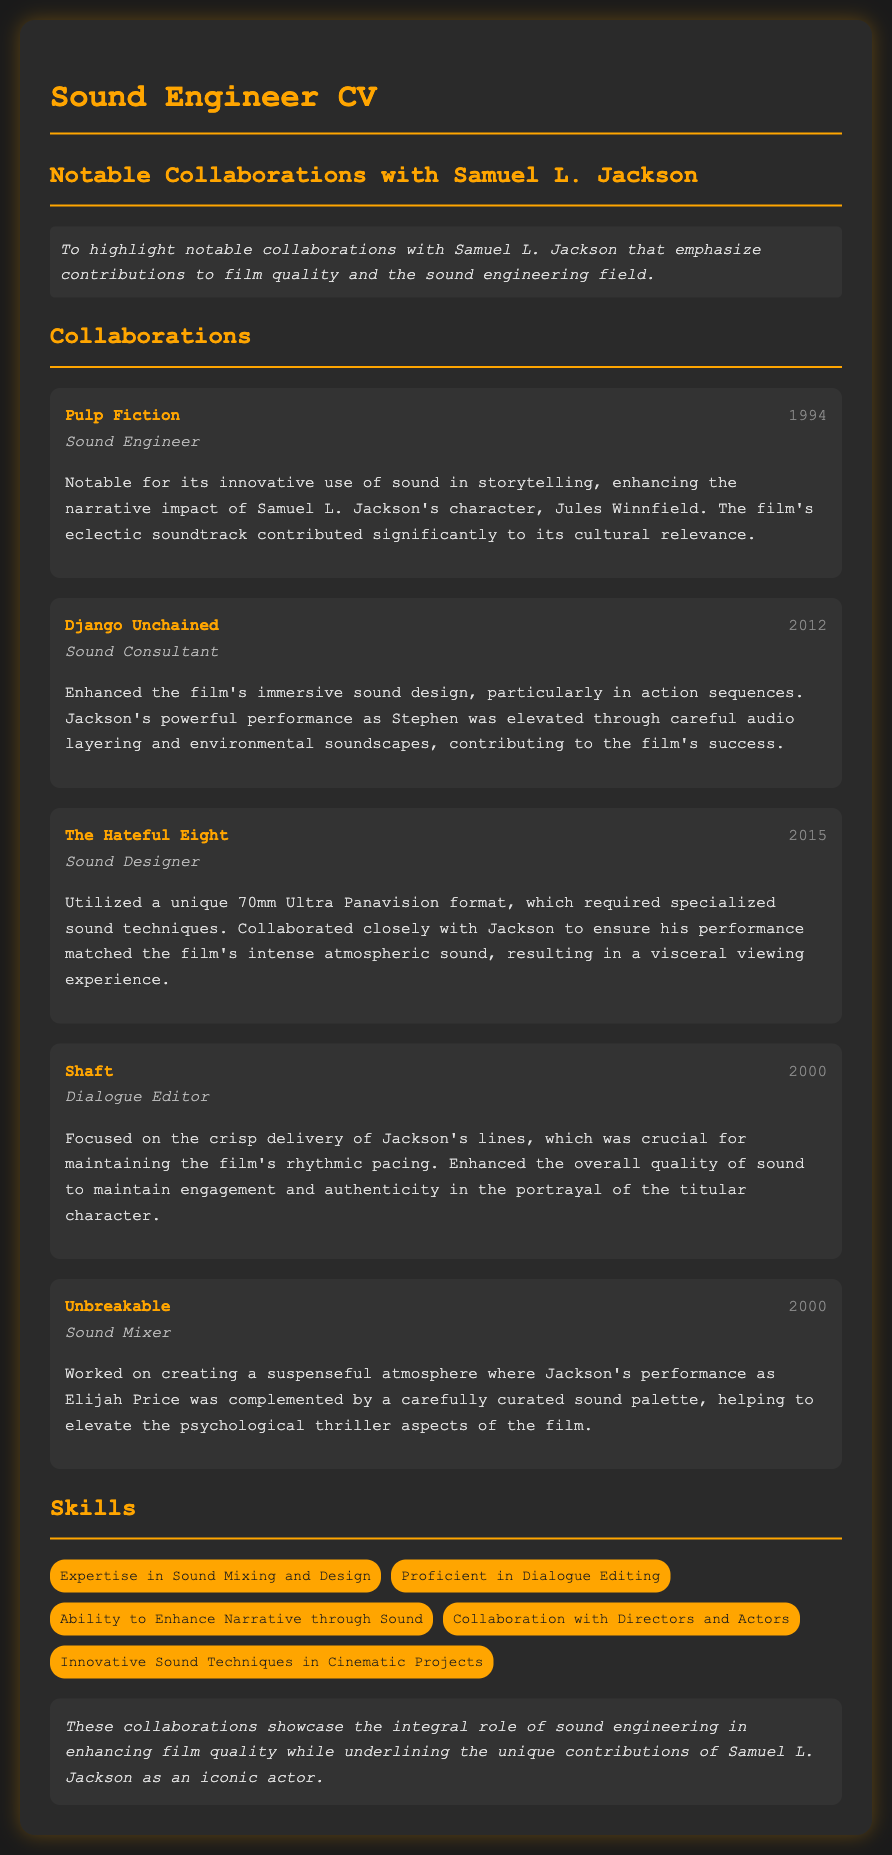What is the title of the CV? The title of the CV is indicated in the document header, which is "Sound Engineer CV".
Answer: Sound Engineer CV In which year was "Pulp Fiction" released? The year of release for "Pulp Fiction" is listed next to the project title in the document.
Answer: 1994 What role did you have in "The Hateful Eight"? The role in "The Hateful Eight" is specified in the project description section of the document.
Answer: Sound Designer Which film featured Samuel L. Jackson as the character Jules Winnfield? The character is mentioned in the description of the project, indicating the film he starred in.
Answer: Pulp Fiction How did your collaboration impact "Django Unchained"? The impact is discussed in the project description, explaining the enhancement of sound design and audio layering.
Answer: Immersive sound design What is one of the skills mentioned in the CV? The skills section lists various abilities relevant to sound engineering, which can be found in the document.
Answer: Expertise in Sound Mixing and Design What year was "Unbreakable" released? The year is provided next to the film title in the collaboration section of the document.
Answer: 2000 Which film required specialized sound techniques due to its format? This detail is found in the description of the relevant collaboration project in the CV.
Answer: The Hateful Eight 